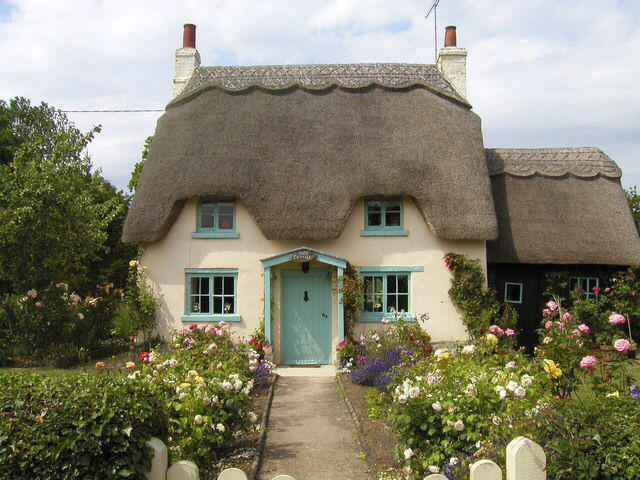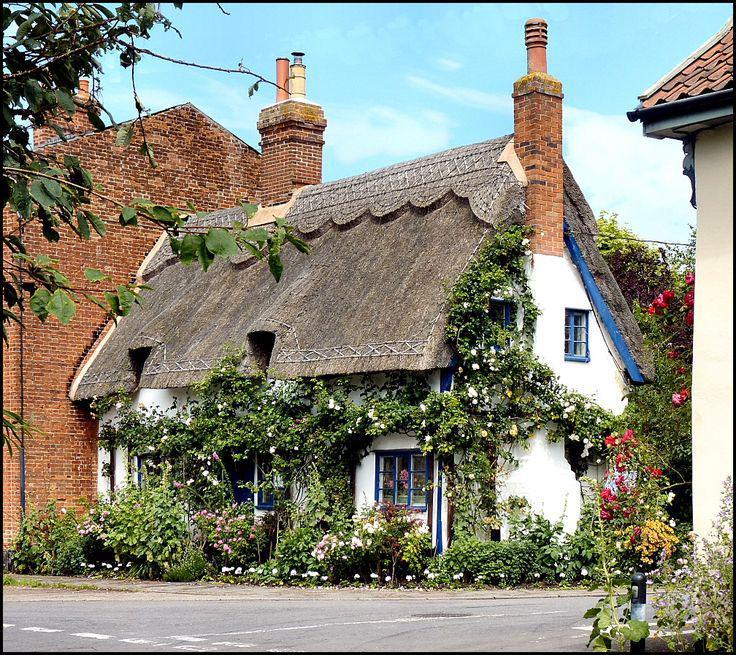The first image is the image on the left, the second image is the image on the right. For the images shown, is this caption "There is a total of five chimneys." true? Answer yes or no. Yes. 